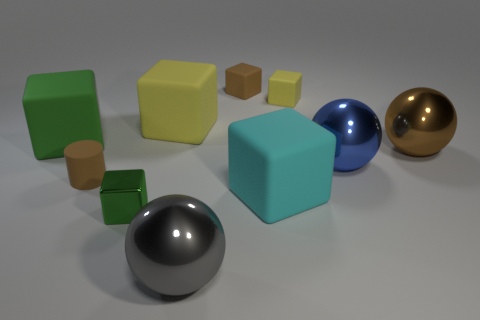What is the size of the cyan object that is the same shape as the big green rubber thing?
Keep it short and to the point. Large. There is another object that is the same color as the small metallic object; what material is it?
Offer a terse response. Rubber. What is the shape of the small brown rubber thing that is on the left side of the shiny ball left of the blue metallic ball?
Your response must be concise. Cylinder. Are there any other rubber objects of the same shape as the big green thing?
Provide a succinct answer. Yes. There is a tiny shiny thing; is it the same color as the large rubber block to the left of the green metal block?
Provide a short and direct response. Yes. The matte thing that is the same color as the cylinder is what size?
Your answer should be compact. Small. Is there a yellow shiny object that has the same size as the blue sphere?
Your answer should be very brief. No. Are the brown cube and the green block that is behind the tiny metal cube made of the same material?
Make the answer very short. Yes. Are there more cyan rubber things than big shiny objects?
Give a very brief answer. No. How many cylinders are either tiny green shiny things or large blue objects?
Your answer should be compact. 0. 